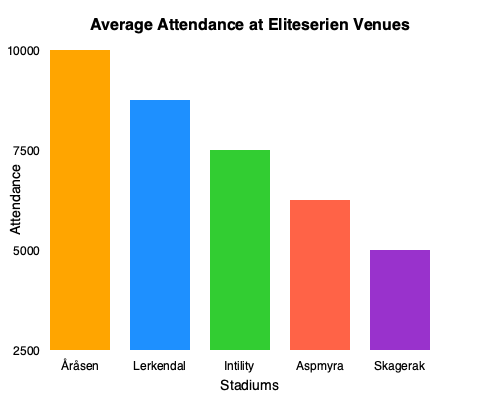Based on the bar chart showing average attendance at Eliteserien venues, how does Åråsen Stadion's attendance compare to the other stadiums, and what percentage of Lerkendal Stadion's attendance does it represent? To answer this question, we need to analyze the bar chart and perform some calculations:

1. Identify Åråsen Stadion's attendance:
   The first bar represents Åråsen Stadion, reaching the 10000 mark.

2. Compare Åråsen to other stadiums:
   - Åråsen (10000) > Lerkendal (8750)
   - Åråsen (10000) > Intility Arena (7500)
   - Åråsen (10000) > Aspmyra Stadion (6250)
   - Åråsen (10000) > Skagerak Arena (5000)

   Åråsen has the highest attendance among the stadiums shown.

3. Calculate the percentage of Lerkendal's attendance:
   Let $x$ be the percentage we're looking for.
   
   $$x = \frac{\text{Åråsen attendance}}{\text{Lerkendal attendance}} \times 100\%$$
   $$x = \frac{10000}{8750} \times 100\% = 1.1429 \times 100\% = 114.29\%$$

Therefore, Åråsen Stadion's attendance is 114.29% of Lerkendal Stadion's attendance.
Answer: Highest; 114.29% 